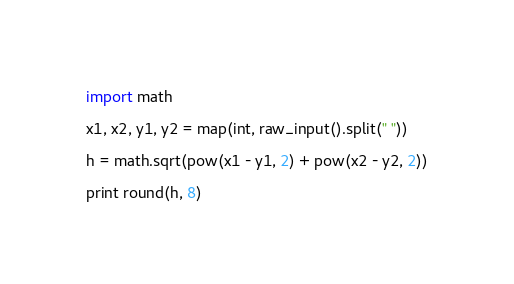<code> <loc_0><loc_0><loc_500><loc_500><_Python_>import math

x1, x2, y1, y2 = map(int, raw_input().split(" "))

h = math.sqrt(pow(x1 - y1, 2) + pow(x2 - y2, 2))

print round(h, 8)</code> 